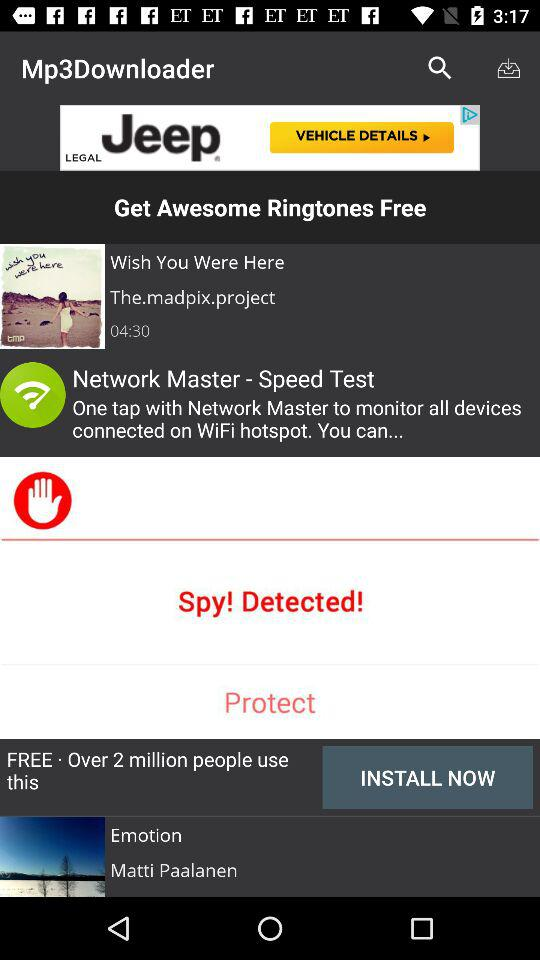What is the duration of the album? The duration of the album is 4 minutes 30 seconds. 